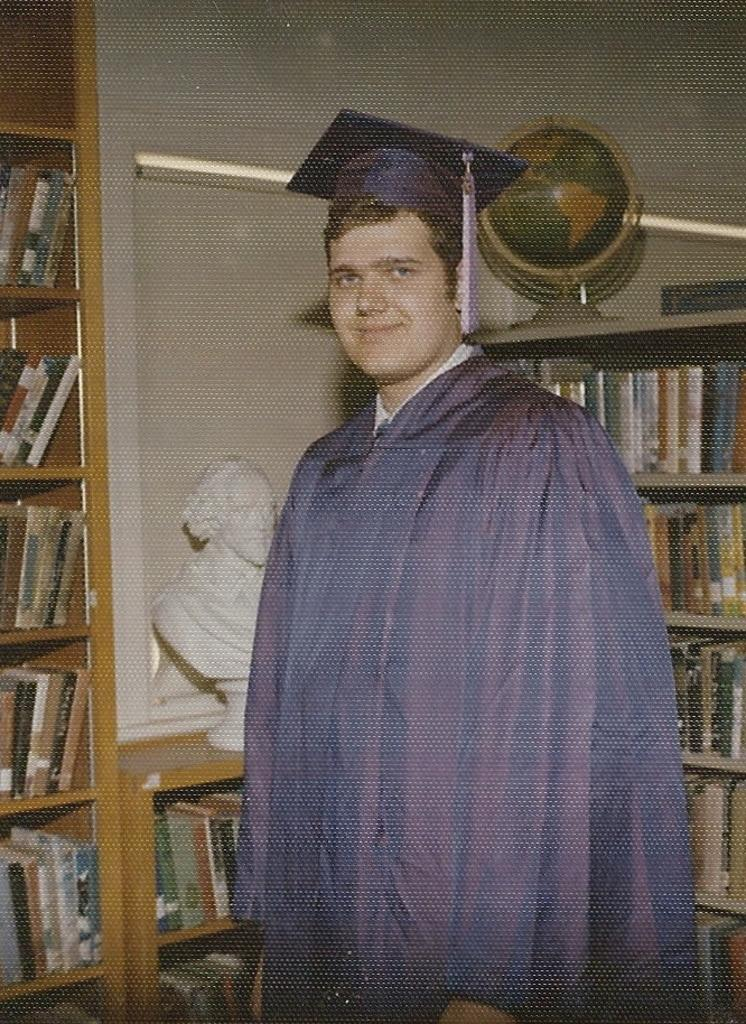What is the person in the image wearing? The person in the image is wearing academic dress. What can be seen on the shelves in the image? There are books on racks in the image. What other object is present in the image? There is a statue in the image. What is located on the right side of the image? There is a globe on the right side of the image. What type of mark can be seen on the owl's feathers in the image? There is no owl present in the image, so it is not possible to determine if there are any marks on its feathers. 